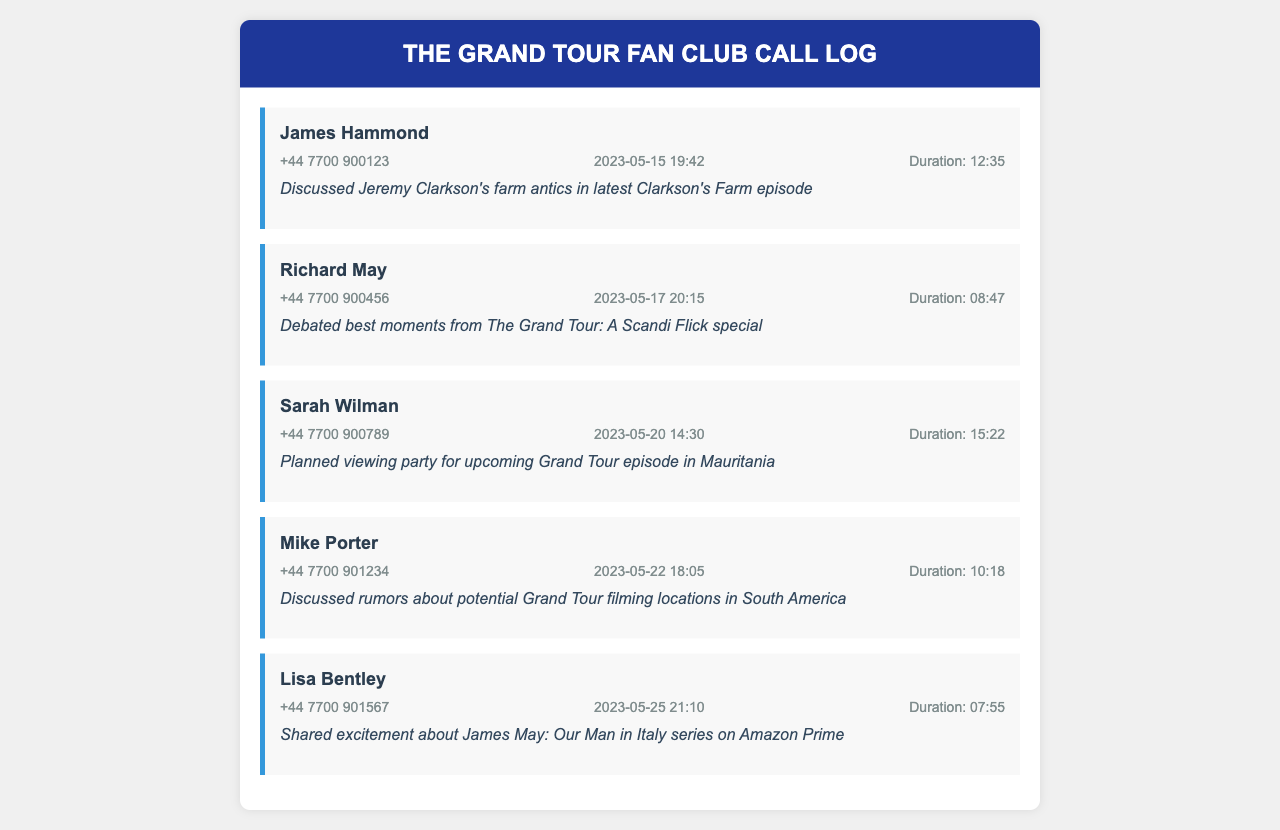What is the name of the first caller? The name of the first caller is listed at the top of the first call entry.
Answer: James Hammond What was discussed in the call with Richard May? The notes in Richard May's call entry specify the topic discussed.
Answer: Best moments from The Grand Tour: A Scandi Flick special What is the duration of the call with Sarah Wilman? The duration is provided in the call entry details for Sarah Wilman.
Answer: 15:22 When did Mike Porter call? The date and time of Mike Porter's call is recorded in the call entry.
Answer: 2023-05-22 18:05 How many calls are recorded in total? The total number of call entries listed in the document can be counted.
Answer: 5 Which caller shared excitement about a series on Amazon Prime? The notes in the call entry indicate who shared excitement about a specific series.
Answer: Lisa Bentley What is the main theme of the call with James Hammond? The notes for James Hammond's call describe the main topic discussed.
Answer: Clarkson's Farm antics What is the phone number of Richard May? The call entry for Richard May contains the phone number.
Answer: +44 7700 900456 What was the purpose of the call with Sarah Wilman? The notes in Sarah Wilman's call entry explain the purpose of the call.
Answer: Planned viewing party for upcoming Grand Tour episode in Mauritania 